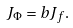<formula> <loc_0><loc_0><loc_500><loc_500>J _ { \Phi } = b J _ { f } .</formula> 